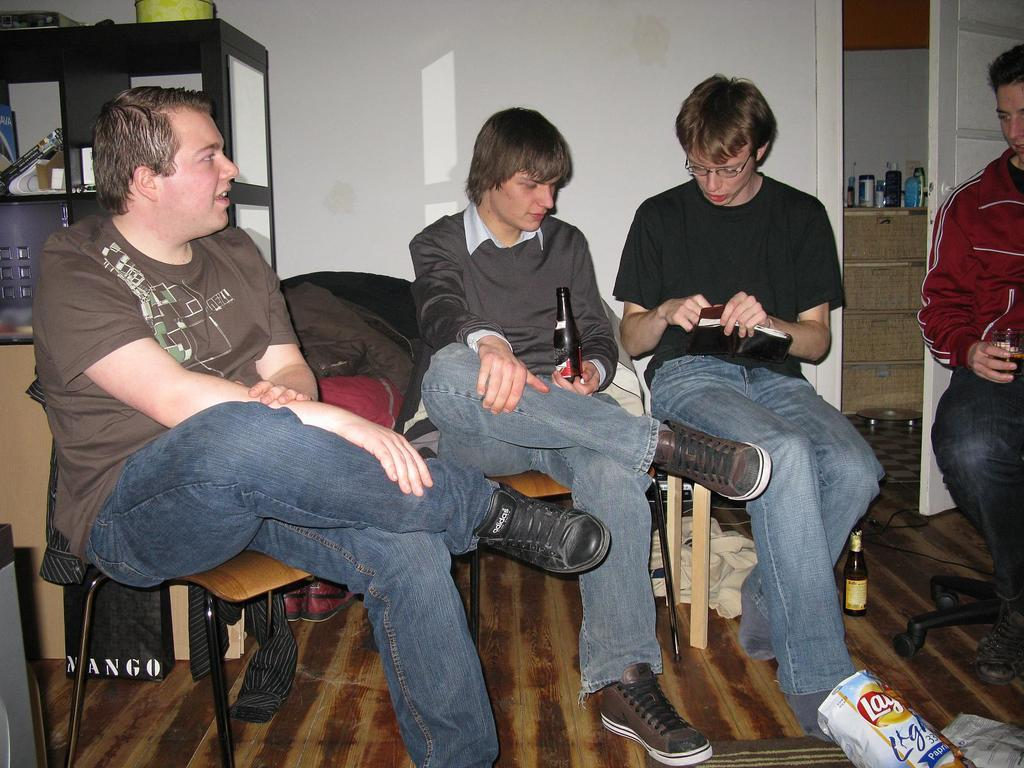What is present in the image that can hold items? There is a rack in the image that can hold items. What is the color of the wall in the image? The wall is white in color. How many people are sitting in the image? There are four people sitting on chairs in the image. What is located in the front of the image? There is a bottle and a cover in the front of the image. Are there any dinosaurs visible in the image? No, there are no dinosaurs present in the image. What type of vest is being worn by the people in the image? The image does not show any vests being worn by the people, so it cannot be determined from the image. 